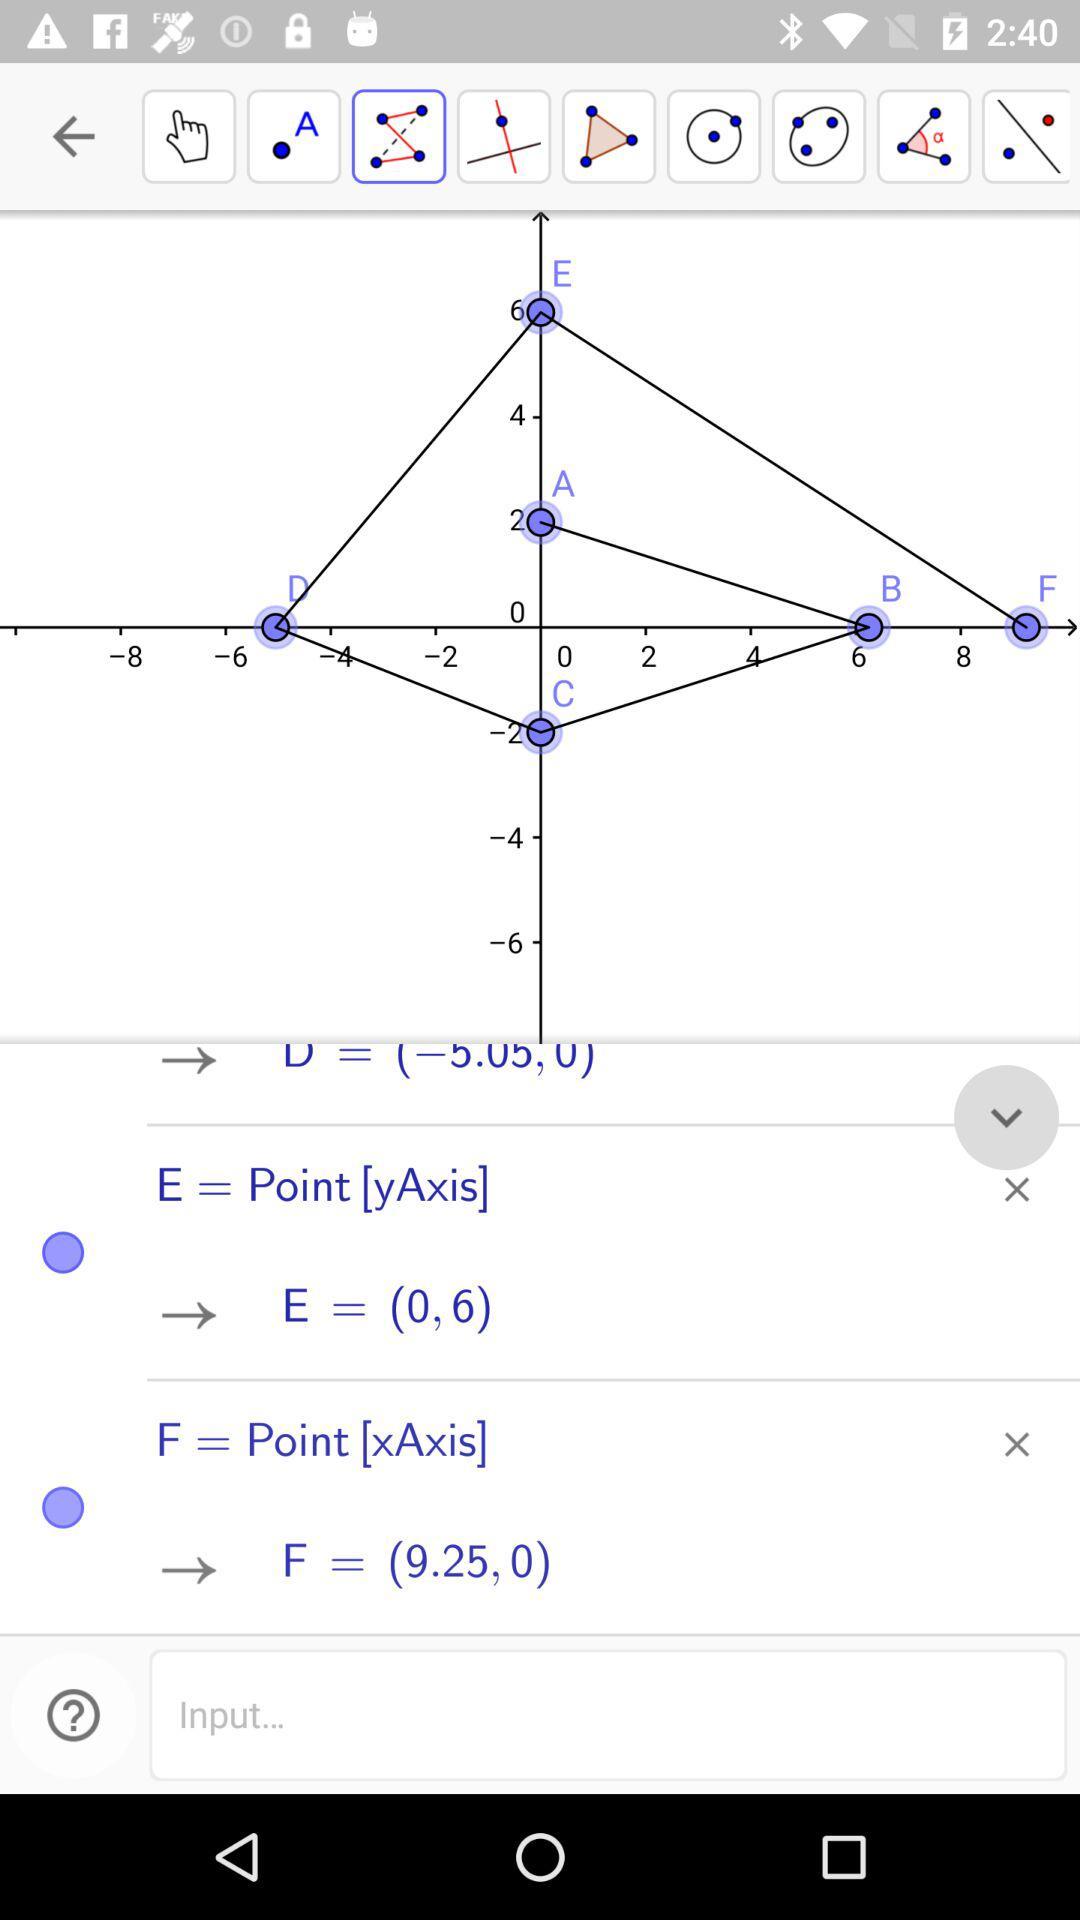What is the sum of the y-coordinates of points D and E?
Answer the question using a single word or phrase. 6 